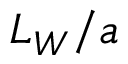<formula> <loc_0><loc_0><loc_500><loc_500>L _ { W } / a</formula> 